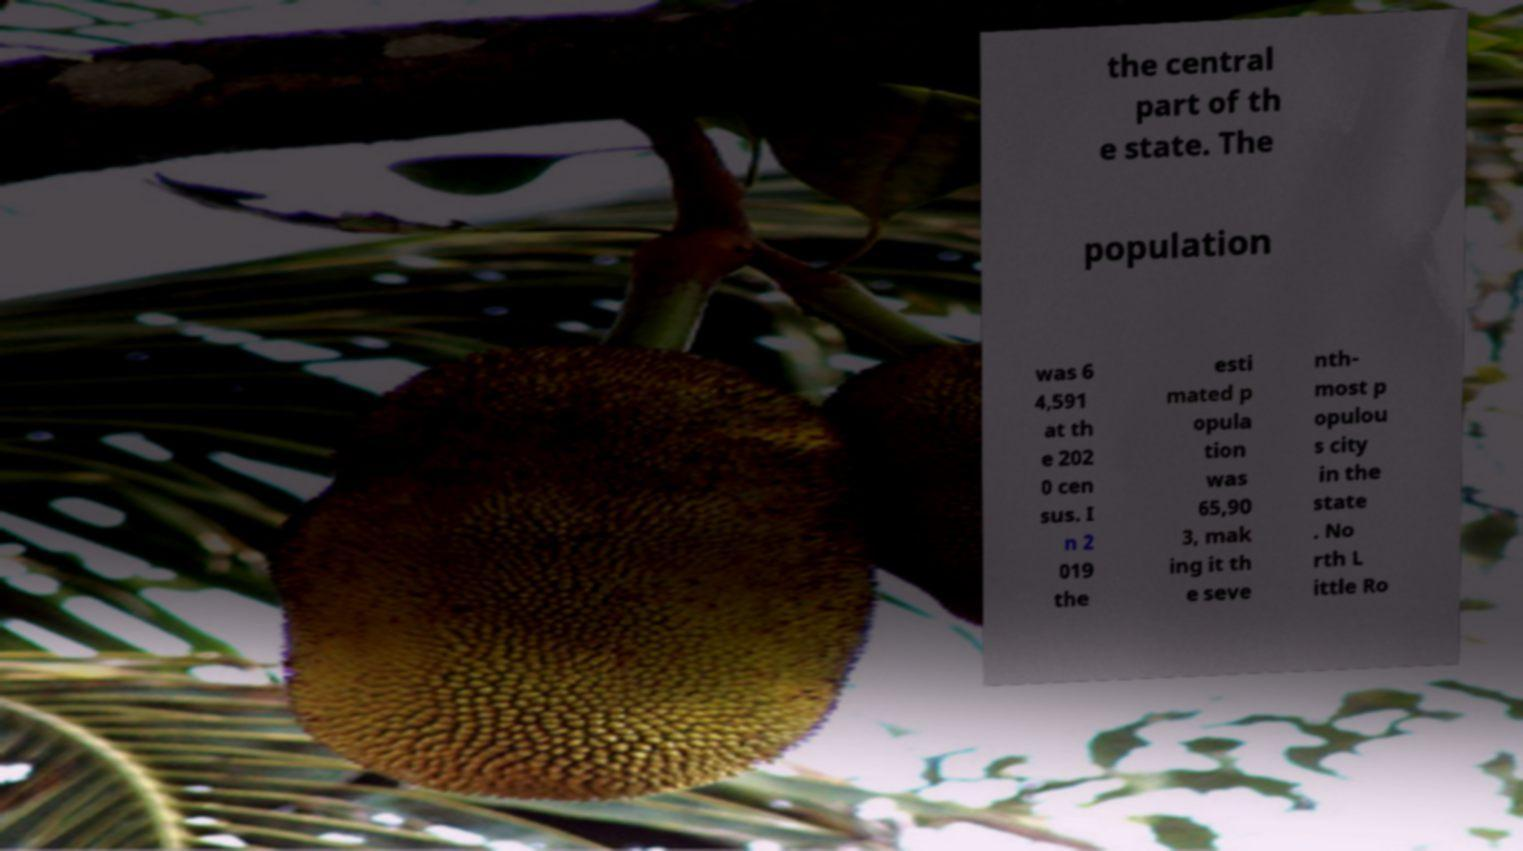What messages or text are displayed in this image? I need them in a readable, typed format. the central part of th e state. The population was 6 4,591 at th e 202 0 cen sus. I n 2 019 the esti mated p opula tion was 65,90 3, mak ing it th e seve nth- most p opulou s city in the state . No rth L ittle Ro 